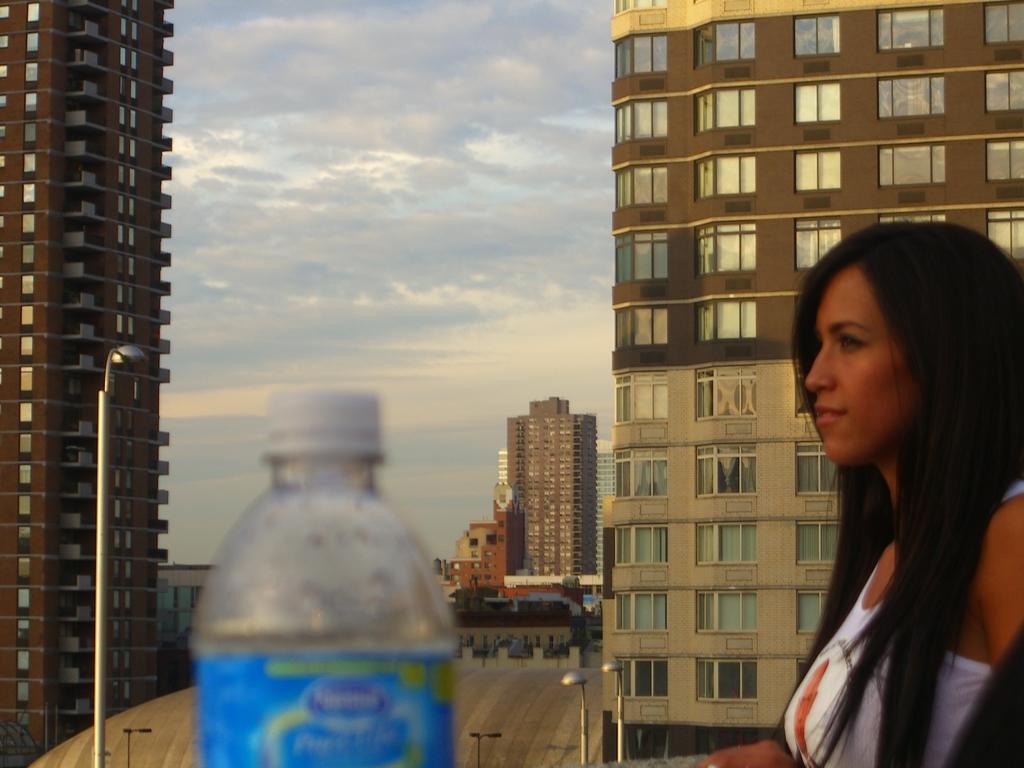In one or two sentences, can you explain what this image depicts? The image is outside of the city. In the image on right side there is a woman, in middle there is a water bottle, on left side there is a street light. In background there are some buildings and sky is on top. 